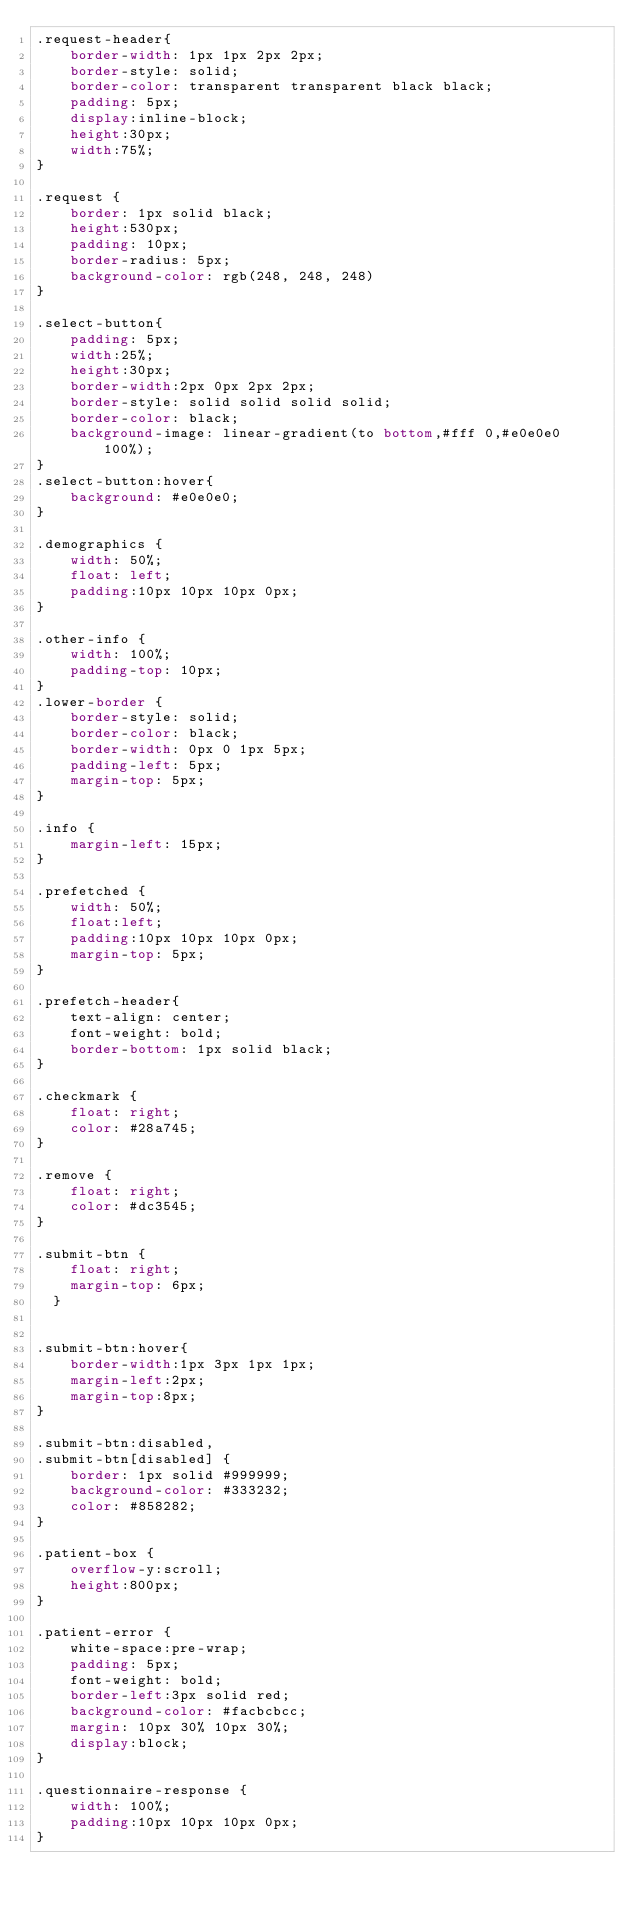Convert code to text. <code><loc_0><loc_0><loc_500><loc_500><_CSS_>.request-header{
    border-width: 1px 1px 2px 2px;
    border-style: solid;
    border-color: transparent transparent black black;
    padding: 5px;
    display:inline-block;
    height:30px;
    width:75%;
}

.request {
    border: 1px solid black;
    height:530px;
    padding: 10px;
    border-radius: 5px;
    background-color: rgb(248, 248, 248)
}

.select-button{
    padding: 5px;
    width:25%;
    height:30px;
    border-width:2px 0px 2px 2px;
    border-style: solid solid solid solid;
    border-color: black;
    background-image: linear-gradient(to bottom,#fff 0,#e0e0e0 100%);
}
.select-button:hover{
    background: #e0e0e0;
}

.demographics {
    width: 50%;
    float: left;
    padding:10px 10px 10px 0px;
}

.other-info {
    width: 100%;
    padding-top: 10px;
}
.lower-border {
    border-style: solid;
    border-color: black;
    border-width: 0px 0 1px 5px;
    padding-left: 5px;
    margin-top: 5px;
}

.info {
    margin-left: 15px;
}

.prefetched {
    width: 50%;
    float:left;
    padding:10px 10px 10px 0px;
    margin-top: 5px;
}

.prefetch-header{ 
    text-align: center;
    font-weight: bold;
    border-bottom: 1px solid black;
}

.checkmark {
    float: right;
    color: #28a745;
}

.remove {
    float: right;
    color: #dc3545;
}

.submit-btn {
    float: right;
    margin-top: 6px;
  }


.submit-btn:hover{
    border-width:1px 3px 1px 1px;
    margin-left:2px;
    margin-top:8px;
}

.submit-btn:disabled,
.submit-btn[disabled] {
    border: 1px solid #999999;
    background-color: #333232;
    color: #858282;
}

.patient-box {
    overflow-y:scroll;
    height:800px;
} 
  
.patient-error {
    white-space:pre-wrap;
    padding: 5px;
    font-weight: bold;
    border-left:3px solid red;
    background-color: #facbcbcc;
    margin: 10px 30% 10px 30%;
    display:block;
}

.questionnaire-response {
    width: 100%;
    padding:10px 10px 10px 0px;
}</code> 